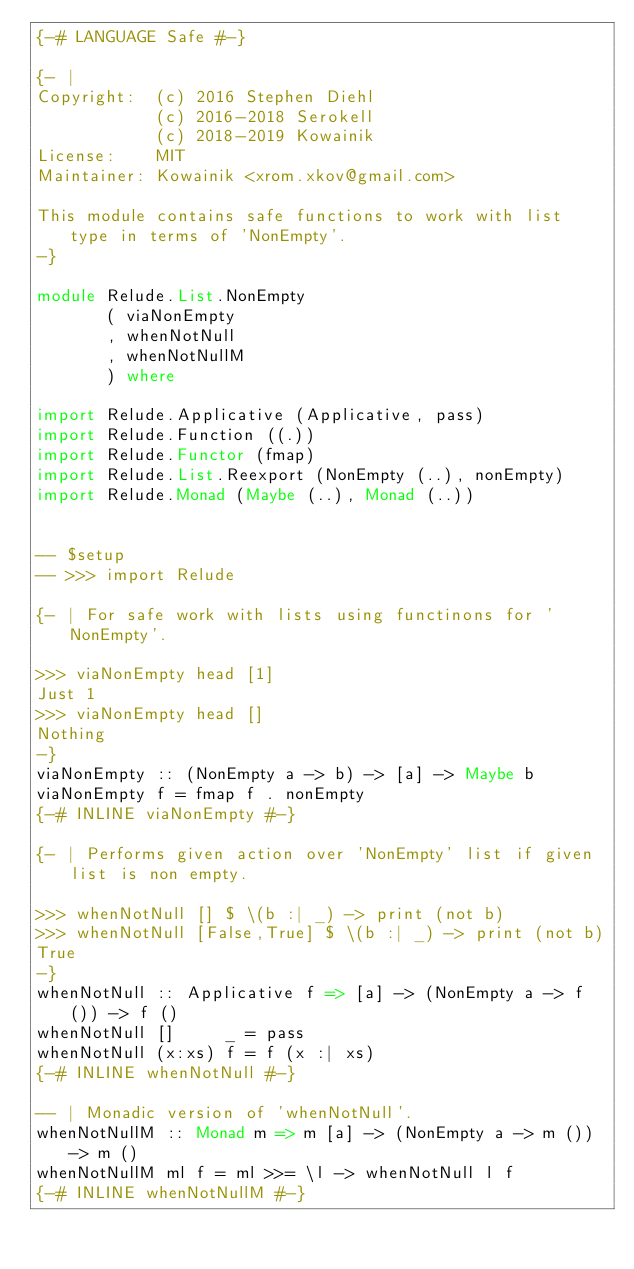<code> <loc_0><loc_0><loc_500><loc_500><_Haskell_>{-# LANGUAGE Safe #-}

{- |
Copyright:  (c) 2016 Stephen Diehl
            (c) 2016-2018 Serokell
            (c) 2018-2019 Kowainik
License:    MIT
Maintainer: Kowainik <xrom.xkov@gmail.com>

This module contains safe functions to work with list type in terms of 'NonEmpty'.
-}

module Relude.List.NonEmpty
       ( viaNonEmpty
       , whenNotNull
       , whenNotNullM
       ) where

import Relude.Applicative (Applicative, pass)
import Relude.Function ((.))
import Relude.Functor (fmap)
import Relude.List.Reexport (NonEmpty (..), nonEmpty)
import Relude.Monad (Maybe (..), Monad (..))


-- $setup
-- >>> import Relude

{- | For safe work with lists using functinons for 'NonEmpty'.

>>> viaNonEmpty head [1]
Just 1
>>> viaNonEmpty head []
Nothing
-}
viaNonEmpty :: (NonEmpty a -> b) -> [a] -> Maybe b
viaNonEmpty f = fmap f . nonEmpty
{-# INLINE viaNonEmpty #-}

{- | Performs given action over 'NonEmpty' list if given list is non empty.

>>> whenNotNull [] $ \(b :| _) -> print (not b)
>>> whenNotNull [False,True] $ \(b :| _) -> print (not b)
True
-}
whenNotNull :: Applicative f => [a] -> (NonEmpty a -> f ()) -> f ()
whenNotNull []     _ = pass
whenNotNull (x:xs) f = f (x :| xs)
{-# INLINE whenNotNull #-}

-- | Monadic version of 'whenNotNull'.
whenNotNullM :: Monad m => m [a] -> (NonEmpty a -> m ()) -> m ()
whenNotNullM ml f = ml >>= \l -> whenNotNull l f
{-# INLINE whenNotNullM #-}
</code> 